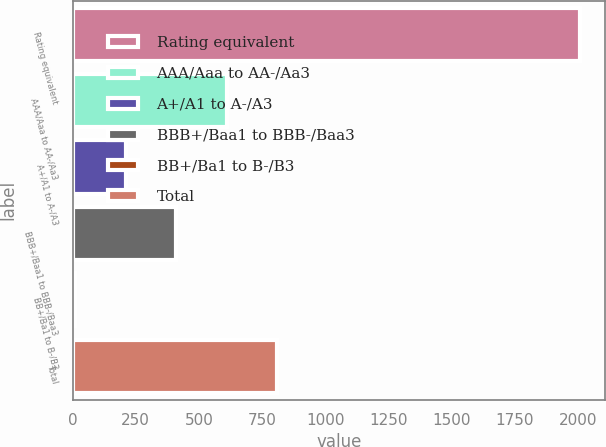Convert chart to OTSL. <chart><loc_0><loc_0><loc_500><loc_500><bar_chart><fcel>Rating equivalent<fcel>AAA/Aaa to AA-/Aa3<fcel>A+/A1 to A-/A3<fcel>BBB+/Baa1 to BBB-/Baa3<fcel>BB+/Ba1 to B-/B3<fcel>Total<nl><fcel>2006<fcel>609.5<fcel>210.5<fcel>410<fcel>11<fcel>809<nl></chart> 